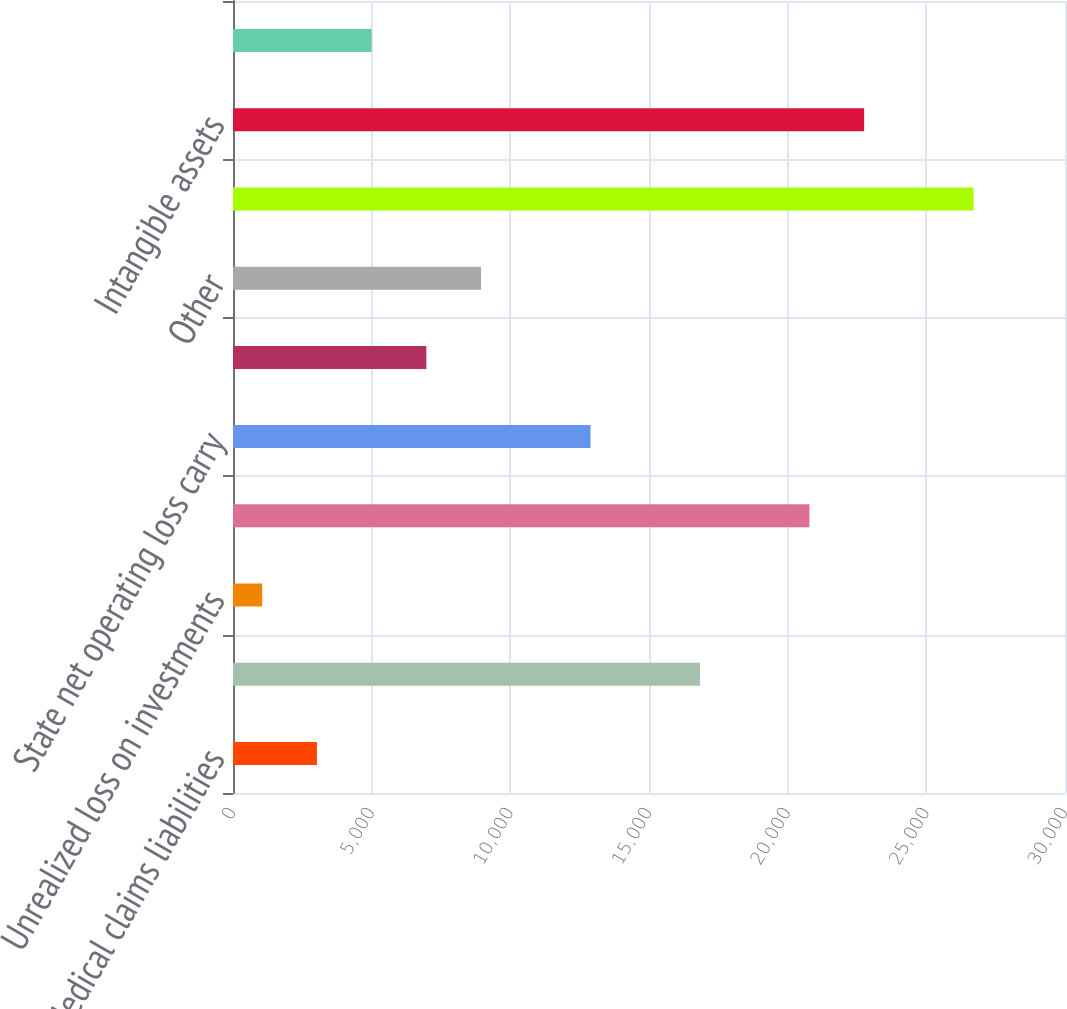Convert chart. <chart><loc_0><loc_0><loc_500><loc_500><bar_chart><fcel>Medical claims liabilities<fcel>Unearned premium and other<fcel>Unrealized loss on investments<fcel>Federal net operating loss<fcel>State net operating loss carry<fcel>Stock compensation<fcel>Other<fcel>Total gross deferred tax<fcel>Intangible assets<fcel>Prepaid assets<nl><fcel>3026.1<fcel>16837.8<fcel>1053<fcel>20784<fcel>12891.6<fcel>6972.3<fcel>8945.4<fcel>26703.3<fcel>22757.1<fcel>4999.2<nl></chart> 